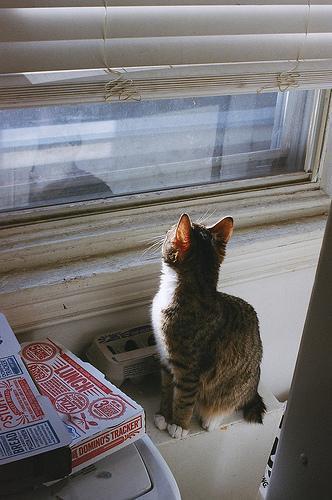How many cats are pictured?
Give a very brief answer. 1. How many doimino's boxes are in this picture?
Give a very brief answer. 2. 